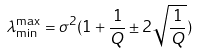Convert formula to latex. <formula><loc_0><loc_0><loc_500><loc_500>\lambda _ { \min } ^ { \max } = \sigma ^ { 2 } ( 1 + \frac { 1 } { Q } \pm 2 \sqrt { \frac { 1 } { Q } } )</formula> 